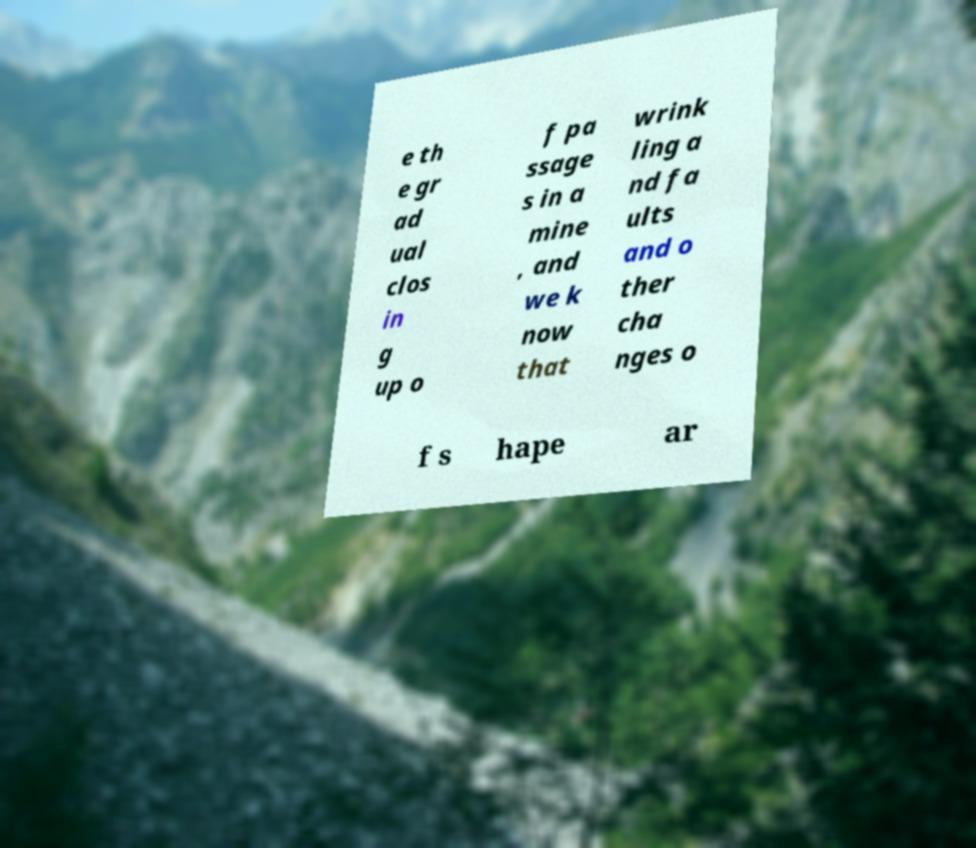I need the written content from this picture converted into text. Can you do that? e th e gr ad ual clos in g up o f pa ssage s in a mine , and we k now that wrink ling a nd fa ults and o ther cha nges o f s hape ar 